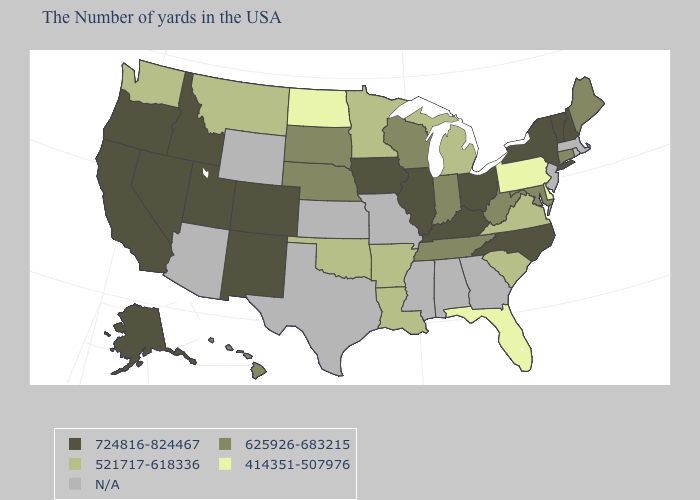Does the first symbol in the legend represent the smallest category?
Short answer required. No. What is the highest value in the USA?
Write a very short answer. 724816-824467. What is the highest value in the West ?
Write a very short answer. 724816-824467. Among the states that border Vermont , which have the lowest value?
Write a very short answer. New Hampshire, New York. Among the states that border Kansas , which have the highest value?
Keep it brief. Colorado. Name the states that have a value in the range 414351-507976?
Keep it brief. Delaware, Pennsylvania, Florida, North Dakota. Name the states that have a value in the range 414351-507976?
Write a very short answer. Delaware, Pennsylvania, Florida, North Dakota. What is the lowest value in the Northeast?
Keep it brief. 414351-507976. Name the states that have a value in the range 414351-507976?
Write a very short answer. Delaware, Pennsylvania, Florida, North Dakota. How many symbols are there in the legend?
Concise answer only. 5. Among the states that border Texas , does New Mexico have the highest value?
Answer briefly. Yes. What is the highest value in the West ?
Keep it brief. 724816-824467. What is the lowest value in states that border New York?
Concise answer only. 414351-507976. What is the value of Arkansas?
Short answer required. 521717-618336. 